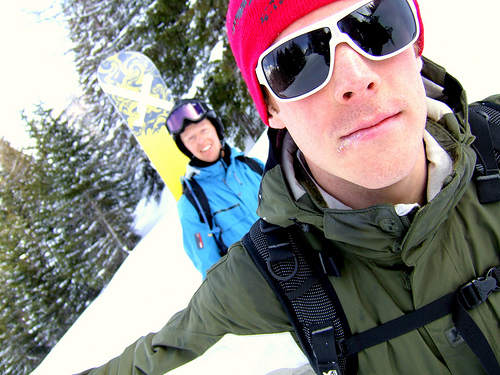<image>
Can you confirm if the snowboard is under the sunglasses? No. The snowboard is not positioned under the sunglasses. The vertical relationship between these objects is different. Is the board behind the glasses? Yes. From this viewpoint, the board is positioned behind the glasses, with the glasses partially or fully occluding the board. Where is the man in relation to the tree? Is it in front of the tree? Yes. The man is positioned in front of the tree, appearing closer to the camera viewpoint. Where is the snow board in relation to the man? Is it in front of the man? No. The snow board is not in front of the man. The spatial positioning shows a different relationship between these objects. 